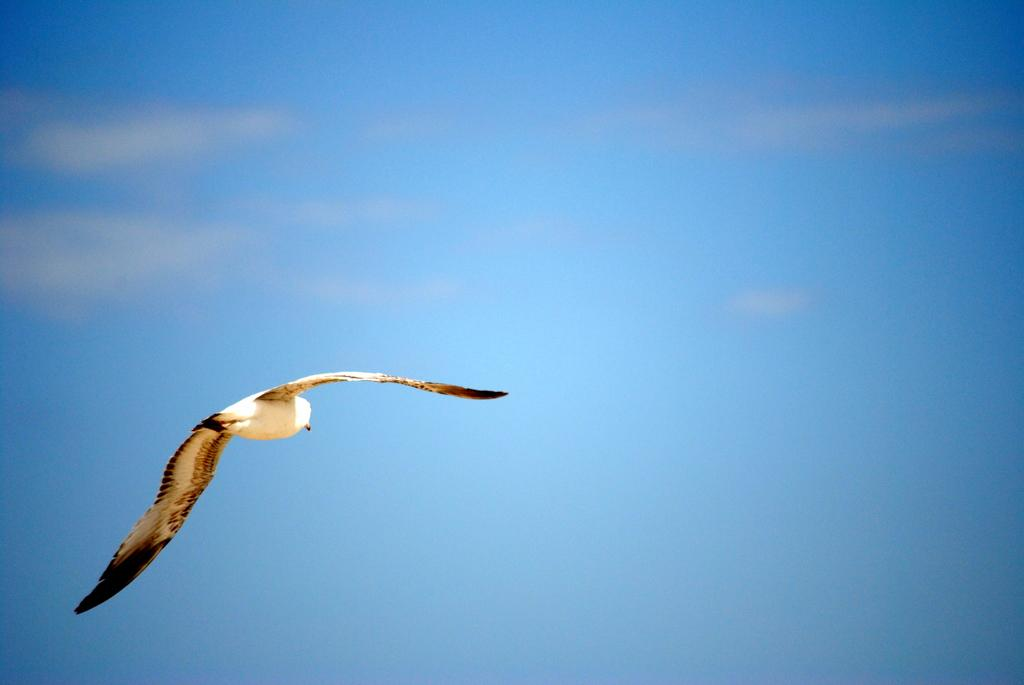What type of animal can be seen in the image? There is a bird in the image. What colors does the bird have? The bird is in white and black color. What is the bird doing in the image? The bird is flying in the air. What can be seen in the background of the image? There is a sky visible in the background of the image. What is the condition of the sky in the image? There are clouds in the sky. How many babies are wrapped in the scarf that the bird is carrying in the image? There is no scarf or babies present in the image; it features a bird flying in the air. What stage of development is the bird in the image? The provided facts do not give information about the bird's development stage. 